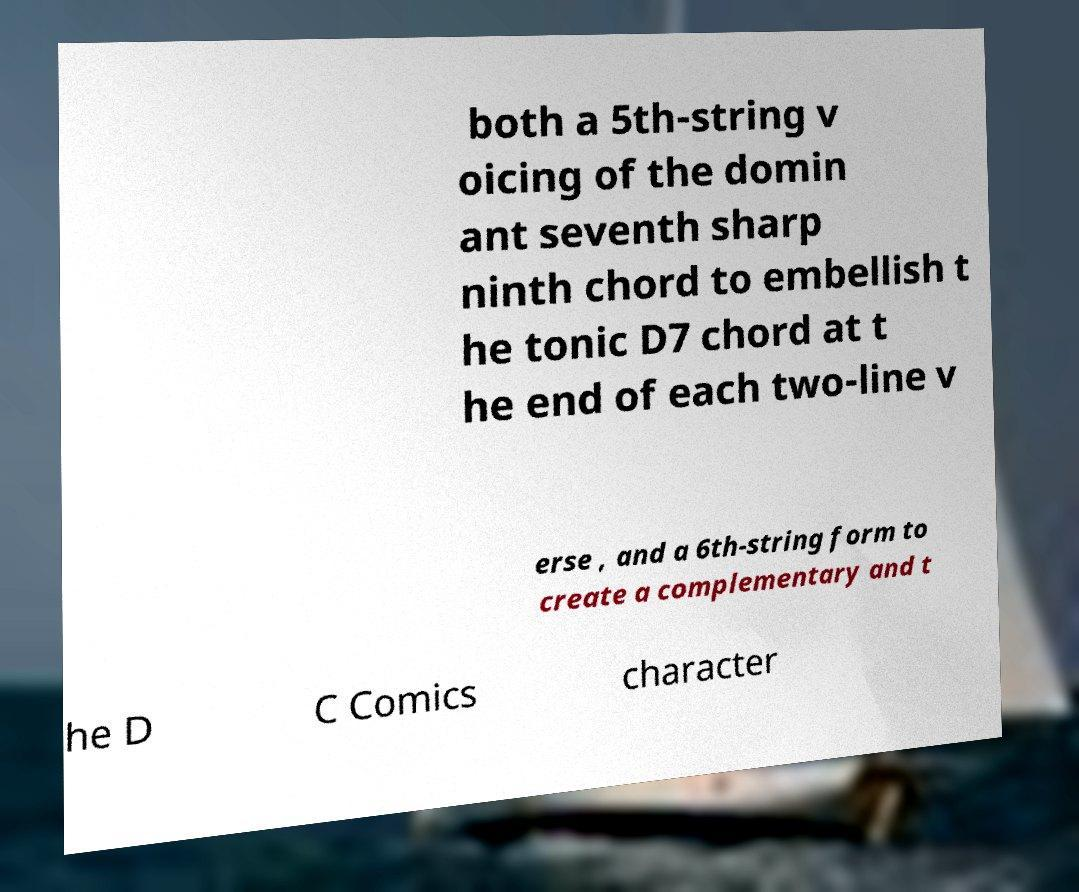Can you read and provide the text displayed in the image?This photo seems to have some interesting text. Can you extract and type it out for me? both a 5th-string v oicing of the domin ant seventh sharp ninth chord to embellish t he tonic D7 chord at t he end of each two-line v erse , and a 6th-string form to create a complementary and t he D C Comics character 